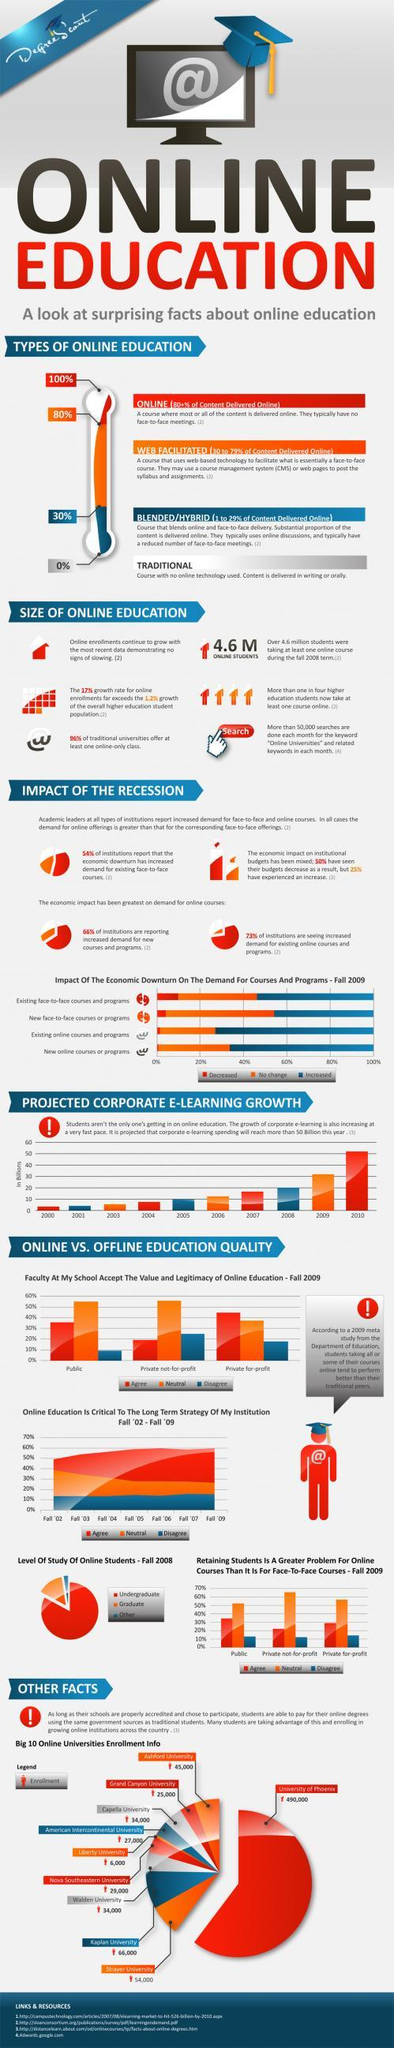In which mode of learning is content delivered 100% in oral or written formats?
Answer the question with a short phrase. traditional 